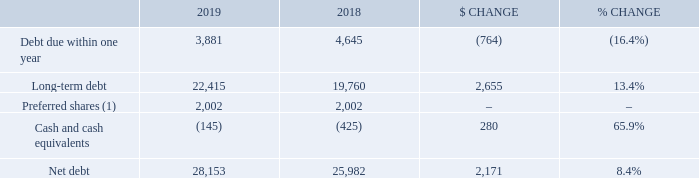6.1 Net debt
(1) 50% of outstanding preferred shares of $4,004 million in 2019 and 2018 are classified as debt consistent with the treatment by some credit rating agencies.
The increase of $1,891 million in total debt, comprised of debt due within one year and long-term debt, was due to: • an increase in our lease liabilities of $2,304 million as a result of the adoption of IFRS 16 on January 1, 2019 • the issuance by Bell Canada of Series M-49 and Series M-50 MTN debentures with total principal amounts of $600  million and $550 million in Canadian dollars, respectively, and Series US-2 Notes with a total principal amount of $600 million in U.S. dollars ($808 million in Canadian dollars) • an increase in our securitized trade receivables of $131 million
Partly offset by: • the early redemption of Series M-27 MTN debentures and Series M-37 debentures with total principal amounts of $1 billion and $400 million, respectively • a decrease in our notes payable (net of issuances) of $1,073 million • a net decrease of $29 million in our lease liabilities and other debt
The decrease in cash and cash equivalents of $280 million was due mainly to: • $2,819 million of dividends paid on BCE common shares • $1,216 million of debt repayments (net of issuances) • $142 million paid for the purchase on the open market of BCE common shares for the settlement of share-based payments • $60 million acquisition and other costs paid
Partly offset by: • $3,818 million of free cash flow • $240 million issuance of common shares from the exercise of stock options
What is the total debt comprised of? Debt due within one year and long-term debt. What is the $ change in cash and cash equivalents? $280 million. What is the $ change in net debt?
Answer scale should be: million. 2,171. What is the Debt due within one year expressed as a ratio of Long-term debt for 2019? 3,881/22,415
Answer: 0.17. What is the percentage of long-term debt over net debt in 2019?
Answer scale should be: percent. 22,415/28,153
Answer: 79.62. What is the change in the net debt in 2019?
Answer scale should be: million. 28,153-25,982
Answer: 2171. 